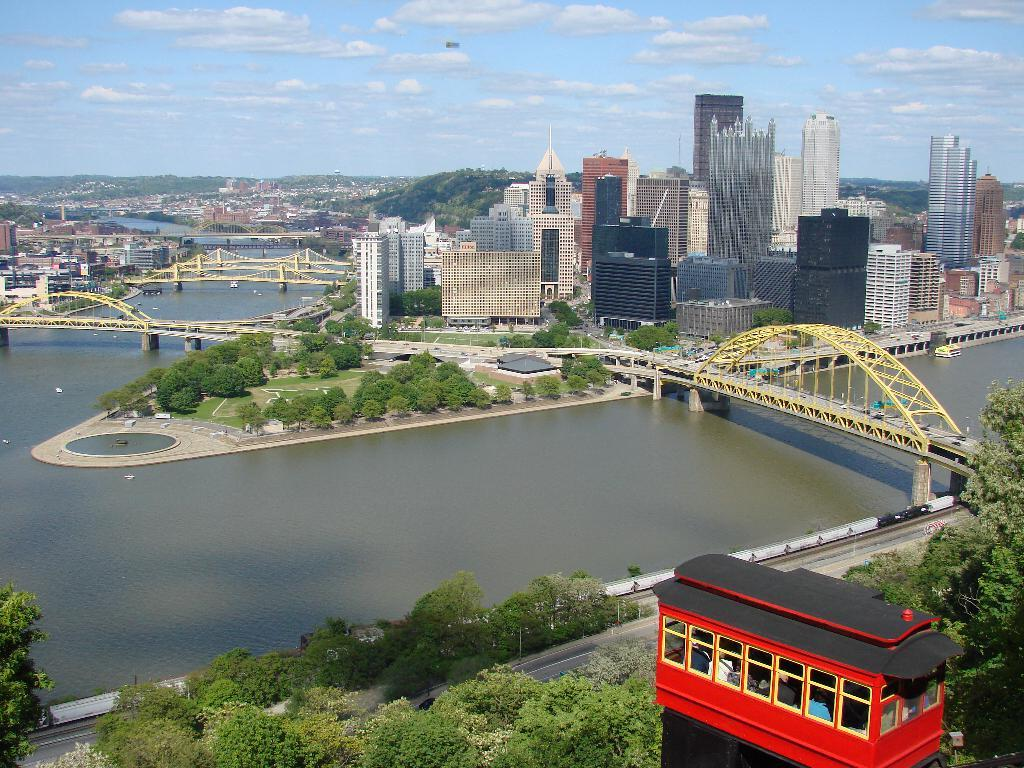What type of water body can be seen in the image? There is a lake in the image. What structures are present in the image that allow people to cross the lake? There are bridges in the image. What architectural elements can be seen in the image? There are pillars in the image. What type of vegetation is present in the image? There are trees in the image. What type of transportation route is visible in the image? There is a road in the image. What type of man-made structures are present in the image? There are buildings in the image. What is the condition of the sky in the image? The sky is visible in the image and appears cloudy. What type of pleasure event is taking place in the image? There is no indication of a pleasure event taking place in the image. Can you describe the maid's attire in the image? There is no maid present in the image. 